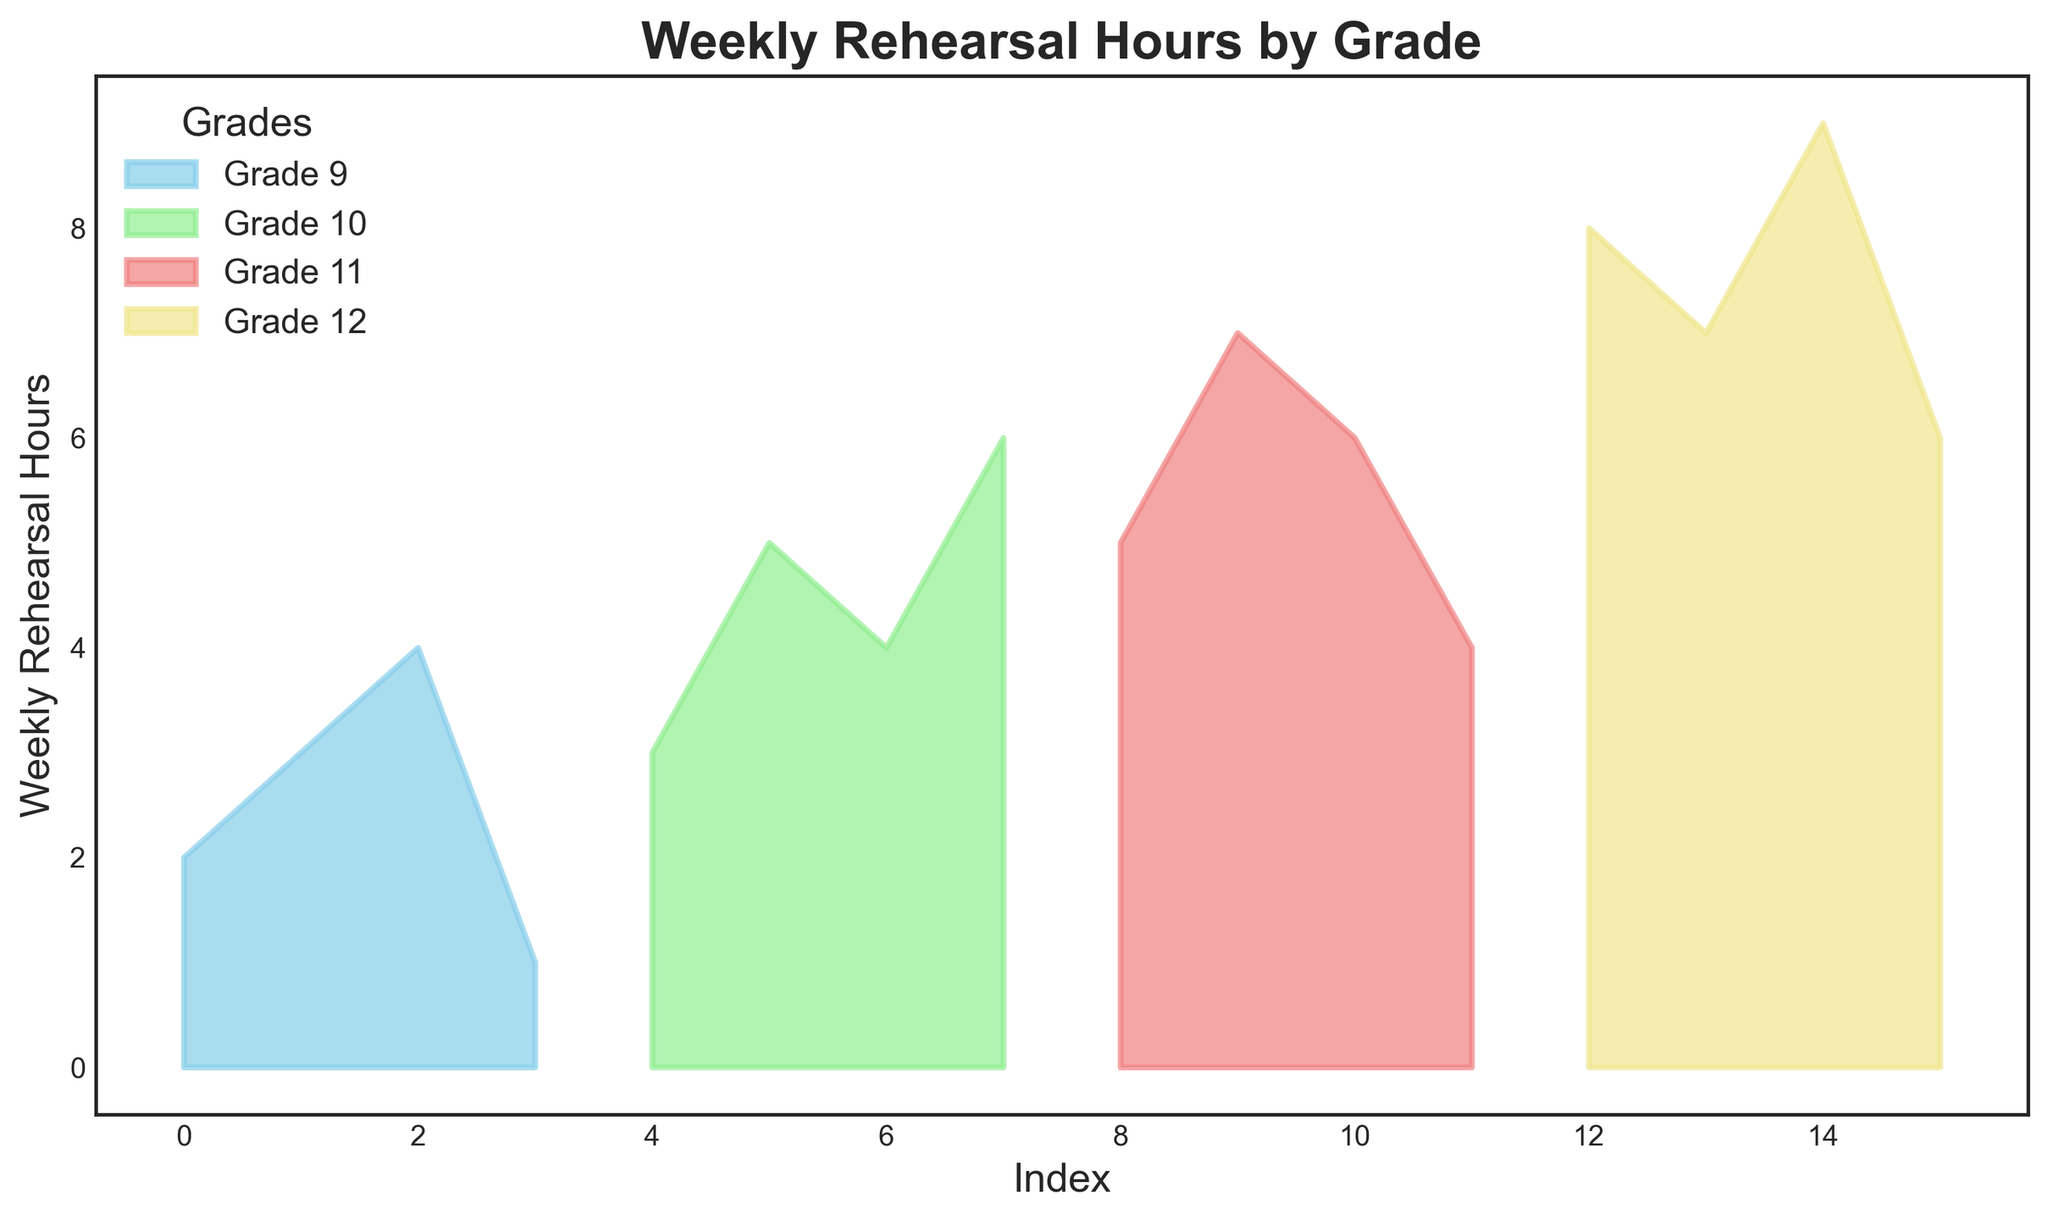How many grades are represented in the figure? The labels in the legend indicate the different grade levels, which are listed as Grade 9, Grade 10, Grade 11, and Grade 12.
Answer: 4 Which grade has the highest peak in weekly rehearsal hours? Comparing the peak values visually, Grade 12 has the highest peak at around 9 weekly rehearsal hours.
Answer: Grade 12 What is the range of weekly rehearsal hours for Grade 11? The visual span for Grade 11 extends from about 4 to 7 weekly rehearsal hours. Range is calculated by subtracting the minimum value from the maximum value: 7 - 4 = 3
Answer: 3 Which two grades have the closest average weekly rehearsal hours? By visually estimating the average area of each grade's segment, we see that Grade 11 and Grade 12 appear to have similar average heights. Average values are around 5-6 hours for both grades.
Answer: Grade 11 and Grade 12 For which grade is the distribution of weekly rehearsal hours the most varied? Grade 12 shows the greatest spread from 6 to 9 hours, indicating the highest variation compared to the others.
Answer: Grade 12 Which grade level spends the least amount of weekly rehearsal hours at any point? By looking at the colored areas, Grade 9 has the lowest point, going down to 1 hour.
Answer: Grade 9 How does the maximum weekly rehearsal hours of Grade 9 compare with Grade 10? Grade 9 reaches a maximum of about 4 hours, while Grade 10 peaks at around 6 hours.
Answer: Grade 10 is higher What's the cumulative weekly rehearsal hours for Grade 10 and Grade 11? Summing the maximum points seen for Grade 10 (6 hours) and Grade 11 (7 hours), we get 6 + 7 = 13 hours.
Answer: 13 What is the difference in peak rehearsal hours between Grade 11 and Grade 12? Grade 11 peaks at 7 hours and Grade 12 at 9 hours. The difference is calculated as 9 - 7 = 2.
Answer: 2 